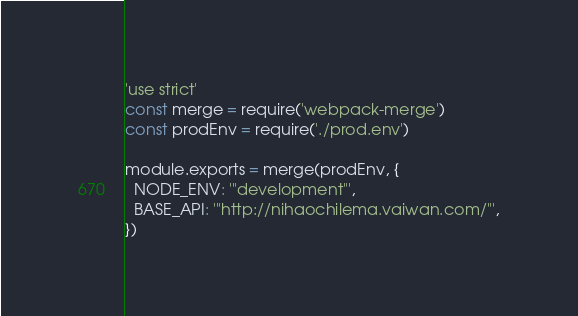Convert code to text. <code><loc_0><loc_0><loc_500><loc_500><_JavaScript_>'use strict'
const merge = require('webpack-merge')
const prodEnv = require('./prod.env')

module.exports = merge(prodEnv, {
  NODE_ENV: '"development"',
  BASE_API: '"http://nihaochilema.vaiwan.com/"',
})
</code> 